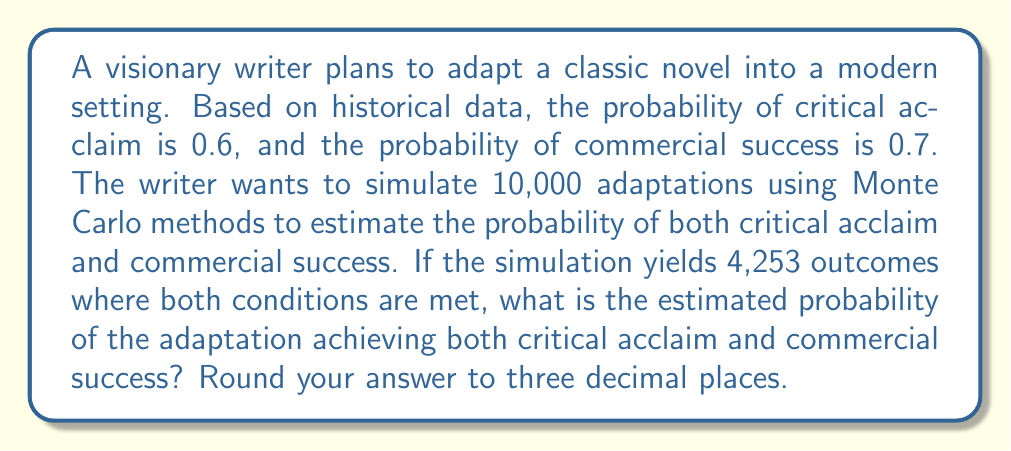Help me with this question. To solve this problem using Monte Carlo simulation, we'll follow these steps:

1. Understand the given probabilities:
   - Probability of critical acclaim: $P(C) = 0.6$
   - Probability of commercial success: $P(S) = 0.7$

2. Recognize that the simulation has been run 10,000 times, which is our total number of trials:
   $N_{total} = 10,000$

3. Note the number of successful outcomes (both conditions met):
   $N_{success} = 4,253$

4. In Monte Carlo simulations, the estimated probability is calculated by dividing the number of successful outcomes by the total number of trials:

   $$P(C \text{ and } S) \approx \frac{N_{success}}{N_{total}}$$

5. Substitute the values:

   $$P(C \text{ and } S) \approx \frac{4,253}{10,000} = 0.4253$$

6. Round the result to three decimal places:

   $$P(C \text{ and } S) \approx 0.425$$

This Monte Carlo estimation closely approximates the theoretical probability, which would be:

$$P(C \text{ and } S) = P(C) \times P(S) = 0.6 \times 0.7 = 0.42$$

The slight difference is due to the randomness inherent in Monte Carlo simulations.
Answer: 0.425 